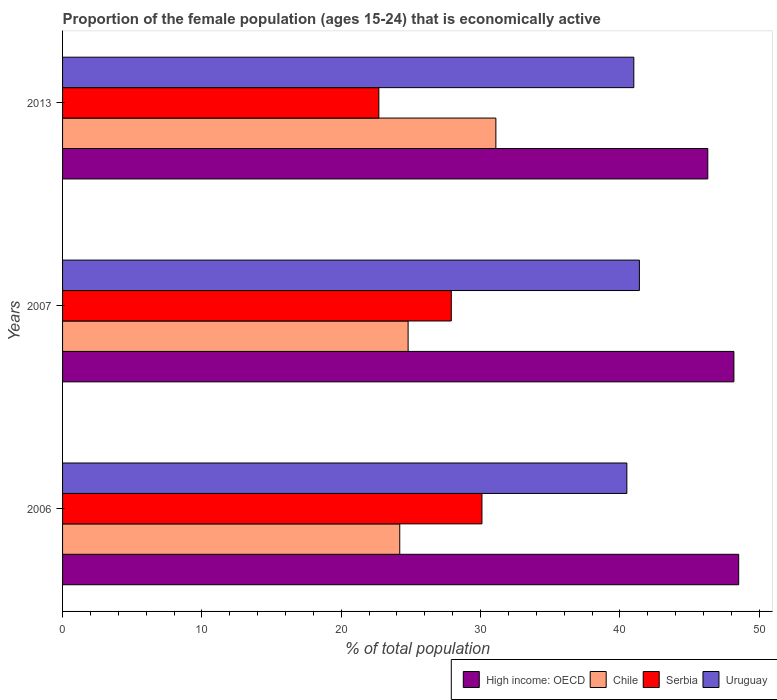How many different coloured bars are there?
Your answer should be compact. 4. Are the number of bars per tick equal to the number of legend labels?
Offer a very short reply. Yes. Are the number of bars on each tick of the Y-axis equal?
Provide a succinct answer. Yes. How many bars are there on the 3rd tick from the bottom?
Offer a very short reply. 4. What is the proportion of the female population that is economically active in High income: OECD in 2006?
Ensure brevity in your answer.  48.53. Across all years, what is the maximum proportion of the female population that is economically active in Uruguay?
Offer a very short reply. 41.4. Across all years, what is the minimum proportion of the female population that is economically active in Serbia?
Provide a succinct answer. 22.7. What is the total proportion of the female population that is economically active in Chile in the graph?
Give a very brief answer. 80.1. What is the difference between the proportion of the female population that is economically active in Chile in 2006 and that in 2007?
Give a very brief answer. -0.6. What is the difference between the proportion of the female population that is economically active in Serbia in 2006 and the proportion of the female population that is economically active in Uruguay in 2007?
Offer a terse response. -11.3. What is the average proportion of the female population that is economically active in Uruguay per year?
Provide a short and direct response. 40.97. In the year 2007, what is the difference between the proportion of the female population that is economically active in Serbia and proportion of the female population that is economically active in High income: OECD?
Give a very brief answer. -20.28. What is the ratio of the proportion of the female population that is economically active in Serbia in 2006 to that in 2007?
Ensure brevity in your answer.  1.08. What is the difference between the highest and the second highest proportion of the female population that is economically active in Serbia?
Make the answer very short. 2.2. What is the difference between the highest and the lowest proportion of the female population that is economically active in High income: OECD?
Provide a succinct answer. 2.22. Is the sum of the proportion of the female population that is economically active in High income: OECD in 2007 and 2013 greater than the maximum proportion of the female population that is economically active in Chile across all years?
Make the answer very short. Yes. Is it the case that in every year, the sum of the proportion of the female population that is economically active in Serbia and proportion of the female population that is economically active in High income: OECD is greater than the sum of proportion of the female population that is economically active in Chile and proportion of the female population that is economically active in Uruguay?
Your answer should be very brief. No. What does the 1st bar from the top in 2013 represents?
Give a very brief answer. Uruguay. What does the 2nd bar from the bottom in 2007 represents?
Ensure brevity in your answer.  Chile. Is it the case that in every year, the sum of the proportion of the female population that is economically active in High income: OECD and proportion of the female population that is economically active in Chile is greater than the proportion of the female population that is economically active in Serbia?
Your response must be concise. Yes. Are all the bars in the graph horizontal?
Ensure brevity in your answer.  Yes. What is the difference between two consecutive major ticks on the X-axis?
Your response must be concise. 10. Does the graph contain any zero values?
Keep it short and to the point. No. Where does the legend appear in the graph?
Provide a short and direct response. Bottom right. How many legend labels are there?
Give a very brief answer. 4. What is the title of the graph?
Keep it short and to the point. Proportion of the female population (ages 15-24) that is economically active. What is the label or title of the X-axis?
Keep it short and to the point. % of total population. What is the % of total population in High income: OECD in 2006?
Your answer should be compact. 48.53. What is the % of total population of Chile in 2006?
Give a very brief answer. 24.2. What is the % of total population in Serbia in 2006?
Your answer should be very brief. 30.1. What is the % of total population of Uruguay in 2006?
Give a very brief answer. 40.5. What is the % of total population of High income: OECD in 2007?
Your answer should be compact. 48.18. What is the % of total population of Chile in 2007?
Your answer should be very brief. 24.8. What is the % of total population of Serbia in 2007?
Offer a very short reply. 27.9. What is the % of total population of Uruguay in 2007?
Make the answer very short. 41.4. What is the % of total population of High income: OECD in 2013?
Give a very brief answer. 46.31. What is the % of total population of Chile in 2013?
Offer a very short reply. 31.1. What is the % of total population in Serbia in 2013?
Make the answer very short. 22.7. What is the % of total population of Uruguay in 2013?
Your answer should be very brief. 41. Across all years, what is the maximum % of total population of High income: OECD?
Provide a short and direct response. 48.53. Across all years, what is the maximum % of total population in Chile?
Make the answer very short. 31.1. Across all years, what is the maximum % of total population of Serbia?
Your response must be concise. 30.1. Across all years, what is the maximum % of total population in Uruguay?
Give a very brief answer. 41.4. Across all years, what is the minimum % of total population in High income: OECD?
Provide a short and direct response. 46.31. Across all years, what is the minimum % of total population in Chile?
Provide a succinct answer. 24.2. Across all years, what is the minimum % of total population of Serbia?
Make the answer very short. 22.7. Across all years, what is the minimum % of total population in Uruguay?
Provide a succinct answer. 40.5. What is the total % of total population in High income: OECD in the graph?
Provide a succinct answer. 143.02. What is the total % of total population in Chile in the graph?
Keep it short and to the point. 80.1. What is the total % of total population of Serbia in the graph?
Provide a short and direct response. 80.7. What is the total % of total population of Uruguay in the graph?
Make the answer very short. 122.9. What is the difference between the % of total population in High income: OECD in 2006 and that in 2007?
Make the answer very short. 0.34. What is the difference between the % of total population of Chile in 2006 and that in 2007?
Your response must be concise. -0.6. What is the difference between the % of total population in Serbia in 2006 and that in 2007?
Offer a very short reply. 2.2. What is the difference between the % of total population in Uruguay in 2006 and that in 2007?
Offer a very short reply. -0.9. What is the difference between the % of total population in High income: OECD in 2006 and that in 2013?
Offer a very short reply. 2.22. What is the difference between the % of total population in Chile in 2006 and that in 2013?
Give a very brief answer. -6.9. What is the difference between the % of total population of High income: OECD in 2007 and that in 2013?
Give a very brief answer. 1.87. What is the difference between the % of total population of Chile in 2007 and that in 2013?
Keep it short and to the point. -6.3. What is the difference between the % of total population in Serbia in 2007 and that in 2013?
Your answer should be compact. 5.2. What is the difference between the % of total population of High income: OECD in 2006 and the % of total population of Chile in 2007?
Provide a short and direct response. 23.73. What is the difference between the % of total population of High income: OECD in 2006 and the % of total population of Serbia in 2007?
Make the answer very short. 20.63. What is the difference between the % of total population in High income: OECD in 2006 and the % of total population in Uruguay in 2007?
Provide a short and direct response. 7.13. What is the difference between the % of total population in Chile in 2006 and the % of total population in Uruguay in 2007?
Give a very brief answer. -17.2. What is the difference between the % of total population of High income: OECD in 2006 and the % of total population of Chile in 2013?
Offer a terse response. 17.43. What is the difference between the % of total population of High income: OECD in 2006 and the % of total population of Serbia in 2013?
Keep it short and to the point. 25.83. What is the difference between the % of total population in High income: OECD in 2006 and the % of total population in Uruguay in 2013?
Your answer should be compact. 7.53. What is the difference between the % of total population of Chile in 2006 and the % of total population of Uruguay in 2013?
Your response must be concise. -16.8. What is the difference between the % of total population in Serbia in 2006 and the % of total population in Uruguay in 2013?
Keep it short and to the point. -10.9. What is the difference between the % of total population of High income: OECD in 2007 and the % of total population of Chile in 2013?
Keep it short and to the point. 17.08. What is the difference between the % of total population of High income: OECD in 2007 and the % of total population of Serbia in 2013?
Offer a terse response. 25.48. What is the difference between the % of total population of High income: OECD in 2007 and the % of total population of Uruguay in 2013?
Offer a terse response. 7.18. What is the difference between the % of total population of Chile in 2007 and the % of total population of Uruguay in 2013?
Your answer should be very brief. -16.2. What is the average % of total population in High income: OECD per year?
Your response must be concise. 47.67. What is the average % of total population of Chile per year?
Keep it short and to the point. 26.7. What is the average % of total population in Serbia per year?
Provide a succinct answer. 26.9. What is the average % of total population of Uruguay per year?
Provide a succinct answer. 40.97. In the year 2006, what is the difference between the % of total population in High income: OECD and % of total population in Chile?
Offer a very short reply. 24.33. In the year 2006, what is the difference between the % of total population of High income: OECD and % of total population of Serbia?
Provide a succinct answer. 18.43. In the year 2006, what is the difference between the % of total population of High income: OECD and % of total population of Uruguay?
Your answer should be very brief. 8.03. In the year 2006, what is the difference between the % of total population in Chile and % of total population in Uruguay?
Your answer should be very brief. -16.3. In the year 2007, what is the difference between the % of total population of High income: OECD and % of total population of Chile?
Offer a very short reply. 23.38. In the year 2007, what is the difference between the % of total population of High income: OECD and % of total population of Serbia?
Provide a short and direct response. 20.28. In the year 2007, what is the difference between the % of total population of High income: OECD and % of total population of Uruguay?
Give a very brief answer. 6.78. In the year 2007, what is the difference between the % of total population of Chile and % of total population of Uruguay?
Keep it short and to the point. -16.6. In the year 2013, what is the difference between the % of total population of High income: OECD and % of total population of Chile?
Offer a terse response. 15.21. In the year 2013, what is the difference between the % of total population in High income: OECD and % of total population in Serbia?
Your response must be concise. 23.61. In the year 2013, what is the difference between the % of total population of High income: OECD and % of total population of Uruguay?
Provide a short and direct response. 5.31. In the year 2013, what is the difference between the % of total population of Chile and % of total population of Uruguay?
Your answer should be compact. -9.9. In the year 2013, what is the difference between the % of total population in Serbia and % of total population in Uruguay?
Offer a very short reply. -18.3. What is the ratio of the % of total population in High income: OECD in 2006 to that in 2007?
Ensure brevity in your answer.  1.01. What is the ratio of the % of total population of Chile in 2006 to that in 2007?
Make the answer very short. 0.98. What is the ratio of the % of total population of Serbia in 2006 to that in 2007?
Your response must be concise. 1.08. What is the ratio of the % of total population in Uruguay in 2006 to that in 2007?
Keep it short and to the point. 0.98. What is the ratio of the % of total population of High income: OECD in 2006 to that in 2013?
Make the answer very short. 1.05. What is the ratio of the % of total population of Chile in 2006 to that in 2013?
Provide a succinct answer. 0.78. What is the ratio of the % of total population in Serbia in 2006 to that in 2013?
Offer a very short reply. 1.33. What is the ratio of the % of total population in High income: OECD in 2007 to that in 2013?
Your answer should be very brief. 1.04. What is the ratio of the % of total population in Chile in 2007 to that in 2013?
Your answer should be compact. 0.8. What is the ratio of the % of total population in Serbia in 2007 to that in 2013?
Offer a very short reply. 1.23. What is the ratio of the % of total population of Uruguay in 2007 to that in 2013?
Offer a very short reply. 1.01. What is the difference between the highest and the second highest % of total population in High income: OECD?
Keep it short and to the point. 0.34. What is the difference between the highest and the second highest % of total population of Serbia?
Make the answer very short. 2.2. What is the difference between the highest and the second highest % of total population in Uruguay?
Provide a succinct answer. 0.4. What is the difference between the highest and the lowest % of total population in High income: OECD?
Ensure brevity in your answer.  2.22. 